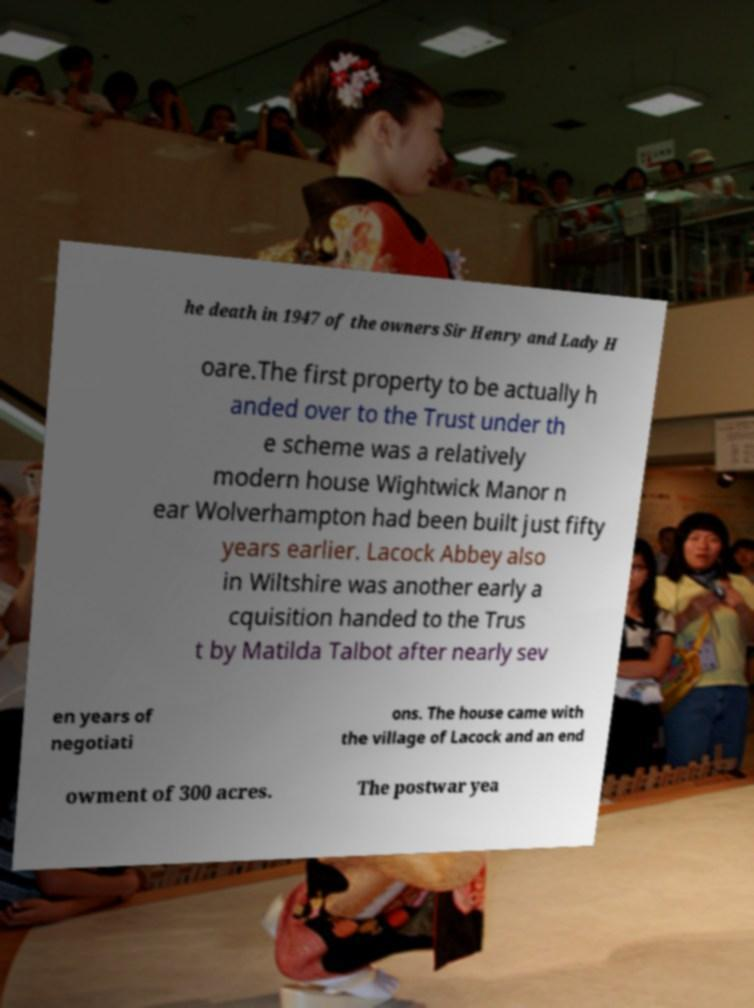Please identify and transcribe the text found in this image. he death in 1947 of the owners Sir Henry and Lady H oare.The first property to be actually h anded over to the Trust under th e scheme was a relatively modern house Wightwick Manor n ear Wolverhampton had been built just fifty years earlier. Lacock Abbey also in Wiltshire was another early a cquisition handed to the Trus t by Matilda Talbot after nearly sev en years of negotiati ons. The house came with the village of Lacock and an end owment of 300 acres. The postwar yea 